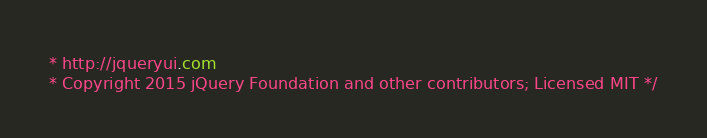Convert code to text. <code><loc_0><loc_0><loc_500><loc_500><_CSS_>* http://jqueryui.com
* Copyright 2015 jQuery Foundation and other contributors; Licensed MIT */
</code> 